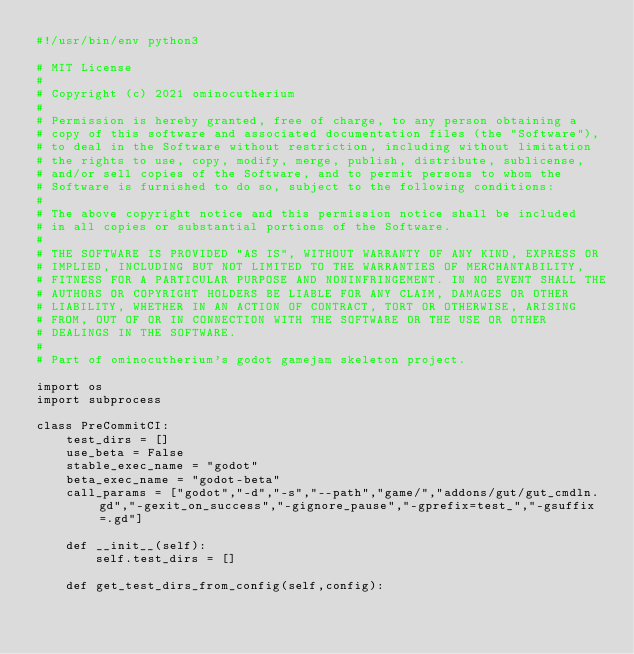<code> <loc_0><loc_0><loc_500><loc_500><_Python_>#!/usr/bin/env python3

# MIT License
# 
# Copyright (c) 2021 ominocutherium
# 
# Permission is hereby granted, free of charge, to any person obtaining a 
# copy of this software and associated documentation files (the "Software"), 
# to deal in the Software without restriction, including without limitation 
# the rights to use, copy, modify, merge, publish, distribute, sublicense, 
# and/or sell copies of the Software, and to permit persons to whom the 
# Software is furnished to do so, subject to the following conditions:
# 
# The above copyright notice and this permission notice shall be included 
# in all copies or substantial portions of the Software.
# 
# THE SOFTWARE IS PROVIDED "AS IS", WITHOUT WARRANTY OF ANY KIND, EXPRESS OR 
# IMPLIED, INCLUDING BUT NOT LIMITED TO THE WARRANTIES OF MERCHANTABILITY, 
# FITNESS FOR A PARTICULAR PURPOSE AND NONINFRINGEMENT. IN NO EVENT SHALL THE 
# AUTHORS OR COPYRIGHT HOLDERS BE LIABLE FOR ANY CLAIM, DAMAGES OR OTHER 
# LIABILITY, WHETHER IN AN ACTION OF CONTRACT, TORT OR OTHERWISE, ARISING 
# FROM, OUT OF OR IN CONNECTION WITH THE SOFTWARE OR THE USE OR OTHER 
# DEALINGS IN THE SOFTWARE.
# 
# Part of ominocutherium's godot gamejam skeleton project.

import os
import subprocess

class PreCommitCI:
    test_dirs = []
    use_beta = False
    stable_exec_name = "godot"
    beta_exec_name = "godot-beta"
    call_params = ["godot","-d","-s","--path","game/","addons/gut/gut_cmdln.gd","-gexit_on_success","-gignore_pause","-gprefix=test_","-gsuffix=.gd"]

    def __init__(self):
        self.test_dirs = []

    def get_test_dirs_from_config(self,config):</code> 